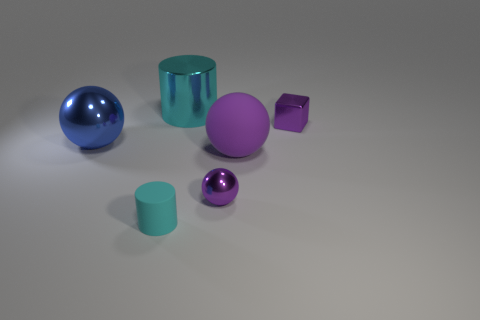Add 2 big red rubber blocks. How many objects exist? 8 Subtract all blocks. How many objects are left? 5 Subtract 0 yellow cylinders. How many objects are left? 6 Subtract all yellow shiny things. Subtract all tiny purple blocks. How many objects are left? 5 Add 2 blue shiny objects. How many blue shiny objects are left? 3 Add 3 tiny purple cubes. How many tiny purple cubes exist? 4 